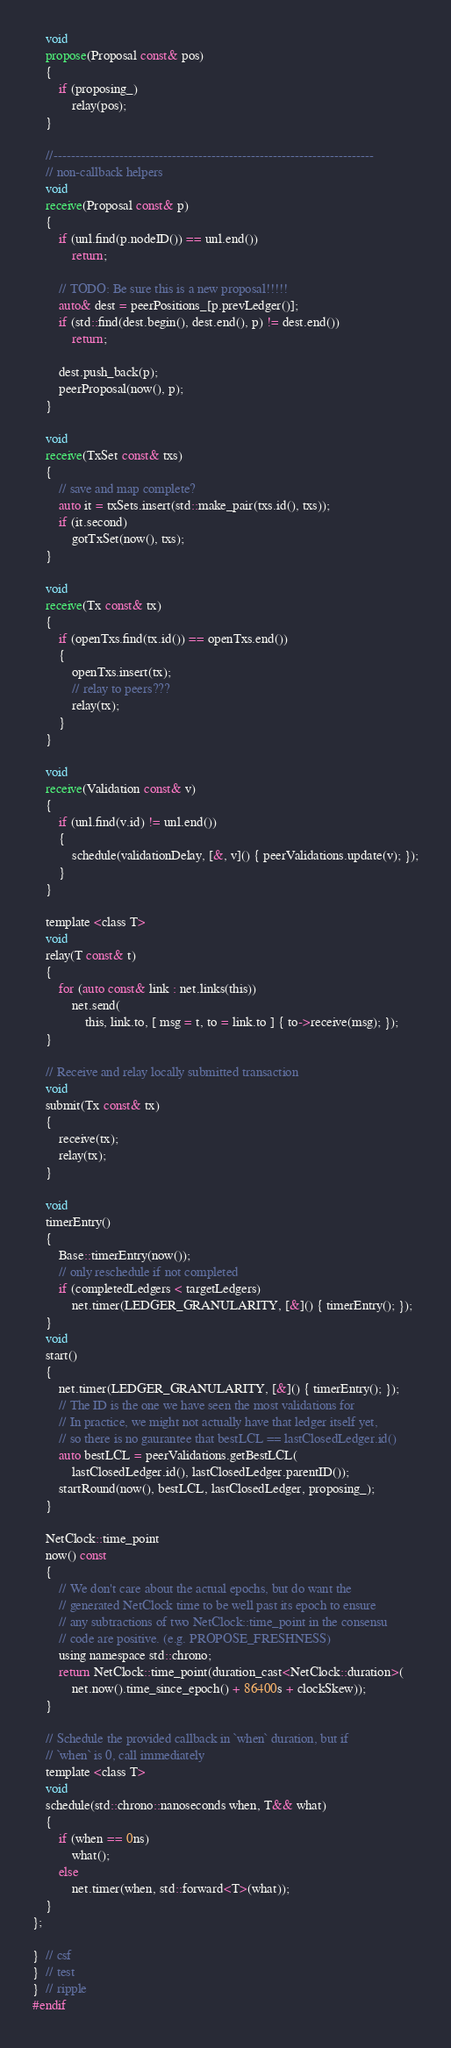Convert code to text. <code><loc_0><loc_0><loc_500><loc_500><_C_>
    void
    propose(Proposal const& pos)
    {
        if (proposing_)
            relay(pos);
    }

    //-------------------------------------------------------------------------
    // non-callback helpers
    void
    receive(Proposal const& p)
    {
        if (unl.find(p.nodeID()) == unl.end())
            return;

        // TODO: Be sure this is a new proposal!!!!!
        auto& dest = peerPositions_[p.prevLedger()];
        if (std::find(dest.begin(), dest.end(), p) != dest.end())
            return;

        dest.push_back(p);
        peerProposal(now(), p);
    }

    void
    receive(TxSet const& txs)
    {
        // save and map complete?
        auto it = txSets.insert(std::make_pair(txs.id(), txs));
        if (it.second)
            gotTxSet(now(), txs);
    }

    void
    receive(Tx const& tx)
    {
        if (openTxs.find(tx.id()) == openTxs.end())
        {
            openTxs.insert(tx);
            // relay to peers???
            relay(tx);
        }
    }

    void
    receive(Validation const& v)
    {
        if (unl.find(v.id) != unl.end())
        {
            schedule(validationDelay, [&, v]() { peerValidations.update(v); });
        }
    }

    template <class T>
    void
    relay(T const& t)
    {
        for (auto const& link : net.links(this))
            net.send(
                this, link.to, [ msg = t, to = link.to ] { to->receive(msg); });
    }

    // Receive and relay locally submitted transaction
    void
    submit(Tx const& tx)
    {
        receive(tx);
        relay(tx);
    }

    void
    timerEntry()
    {
        Base::timerEntry(now());
        // only reschedule if not completed
        if (completedLedgers < targetLedgers)
            net.timer(LEDGER_GRANULARITY, [&]() { timerEntry(); });
    }
    void
    start()
    {
        net.timer(LEDGER_GRANULARITY, [&]() { timerEntry(); });
        // The ID is the one we have seen the most validations for
        // In practice, we might not actually have that ledger itself yet,
        // so there is no gaurantee that bestLCL == lastClosedLedger.id()
        auto bestLCL = peerValidations.getBestLCL(
            lastClosedLedger.id(), lastClosedLedger.parentID());
        startRound(now(), bestLCL, lastClosedLedger, proposing_);
    }

    NetClock::time_point
    now() const
    {
        // We don't care about the actual epochs, but do want the
        // generated NetClock time to be well past its epoch to ensure
        // any subtractions of two NetClock::time_point in the consensu
        // code are positive. (e.g. PROPOSE_FRESHNESS)
        using namespace std::chrono;
        return NetClock::time_point(duration_cast<NetClock::duration>(
            net.now().time_since_epoch() + 86400s + clockSkew));
    }

    // Schedule the provided callback in `when` duration, but if
    // `when` is 0, call immediately
    template <class T>
    void
    schedule(std::chrono::nanoseconds when, T&& what)
    {
        if (when == 0ns)
            what();
        else
            net.timer(when, std::forward<T>(what));
    }
};

}  // csf
}  // test
}  // ripple
#endif
</code> 